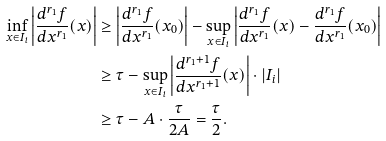<formula> <loc_0><loc_0><loc_500><loc_500>\inf _ { x \in I _ { i } } \left | \frac { d ^ { r _ { 1 } } f } { d x ^ { r _ { 1 } } } ( x ) \right | & \geq \left | \frac { d ^ { r _ { 1 } } f } { d x ^ { r _ { 1 } } } ( x _ { 0 } ) \right | - \sup _ { x \in I _ { i } } \left | \frac { d ^ { r _ { 1 } } f } { d x ^ { r _ { 1 } } } ( x ) - \frac { d ^ { r _ { 1 } } f } { d x ^ { r _ { 1 } } } ( x _ { 0 } ) \right | \\ & \geq \tau - \sup _ { x \in I _ { i } } \left | \frac { d ^ { r _ { 1 } + 1 } f } { d x ^ { r _ { 1 } + 1 } } ( x ) \right | \cdot | I _ { i } | \\ & \geq \tau - A \cdot \frac { \tau } { 2 A } = \frac { \tau } { 2 } .</formula> 